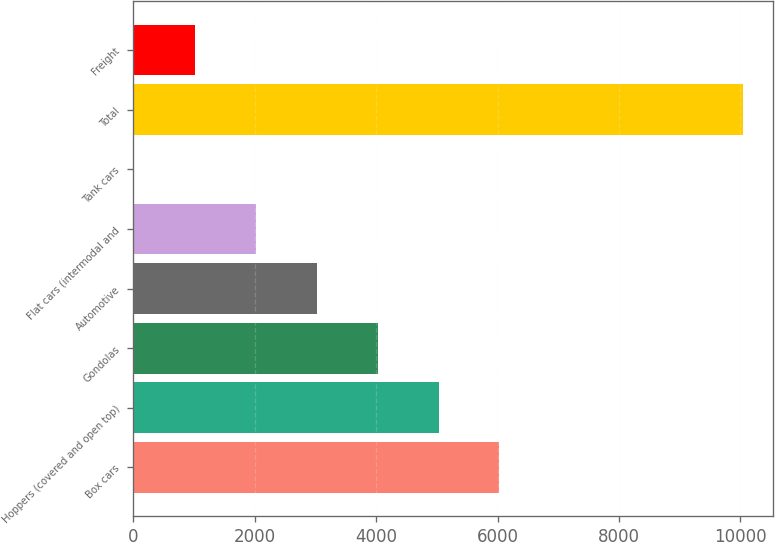<chart> <loc_0><loc_0><loc_500><loc_500><bar_chart><fcel>Box cars<fcel>Hoppers (covered and open top)<fcel>Gondolas<fcel>Automotive<fcel>Flat cars (intermodal and<fcel>Tank cars<fcel>Total<fcel>Freight<nl><fcel>6030.6<fcel>5028<fcel>4025.4<fcel>3022.8<fcel>2020.2<fcel>15<fcel>10041<fcel>1017.6<nl></chart> 